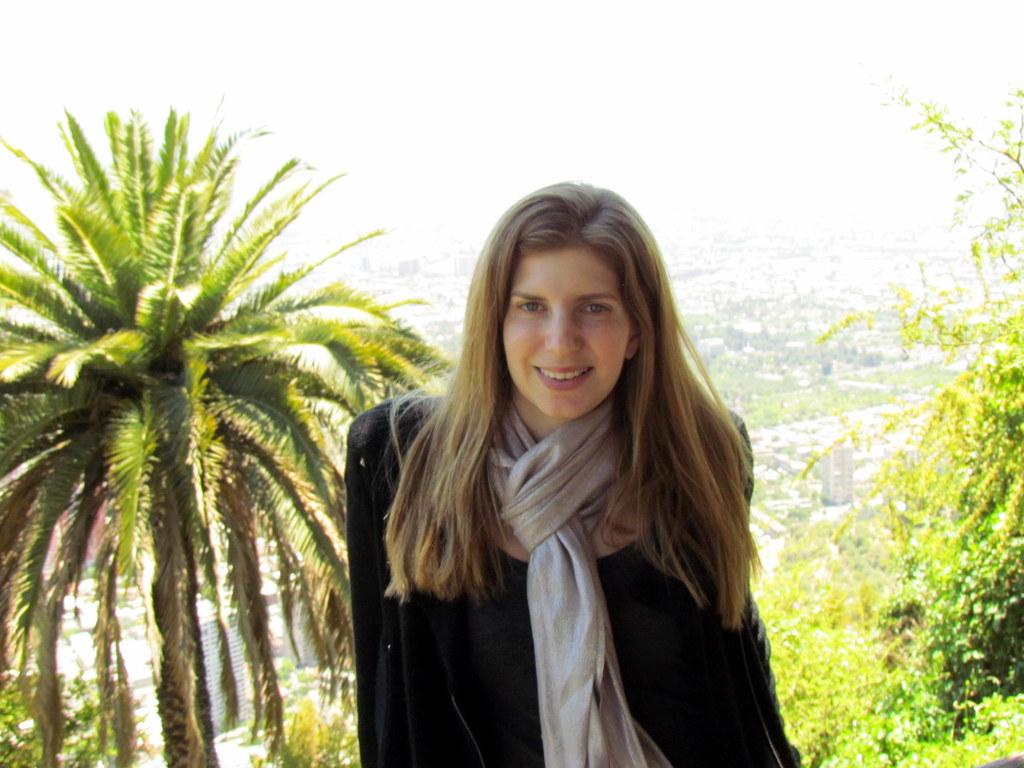Who is the main subject in the image? There is a woman in the image. What is the woman wearing? The woman is wearing a black suit and a necktie. What is the woman's facial expression in the image? The woman is smiling. What is the woman doing in the image? The woman is giving a pose for the picture. What can be seen in the background of the image? There are trees and buildings in the background of the image. How many eyes does the servant have in the image? There is no servant present in the image, and therefore no eyes to count. 